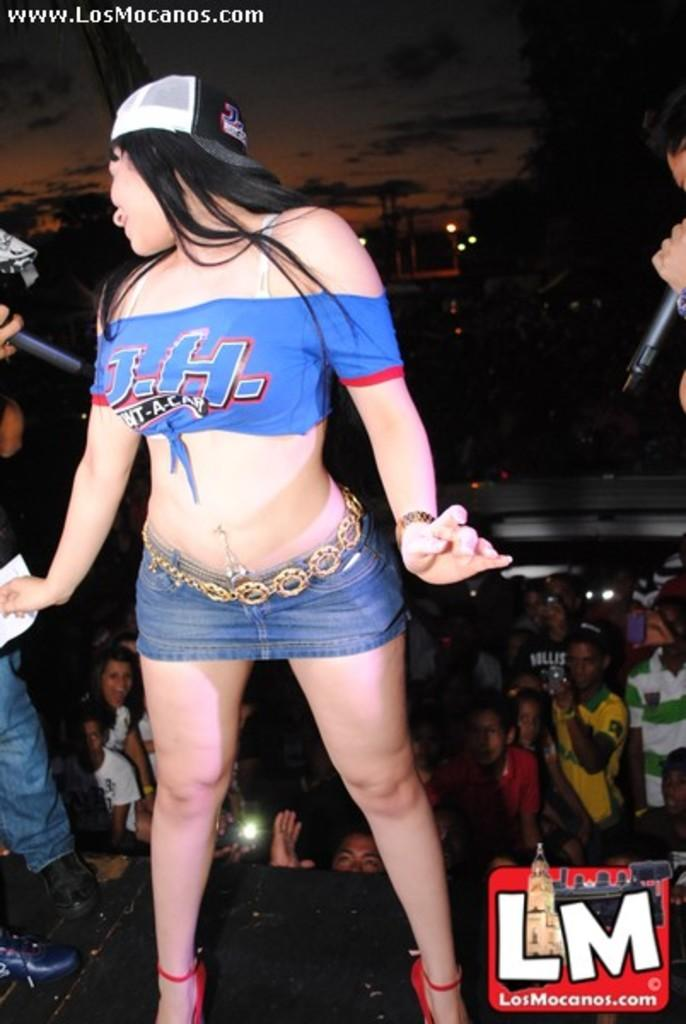<image>
Describe the image concisely. a girl in a small shirt and short skirt is an ad for the losmocanos.com 